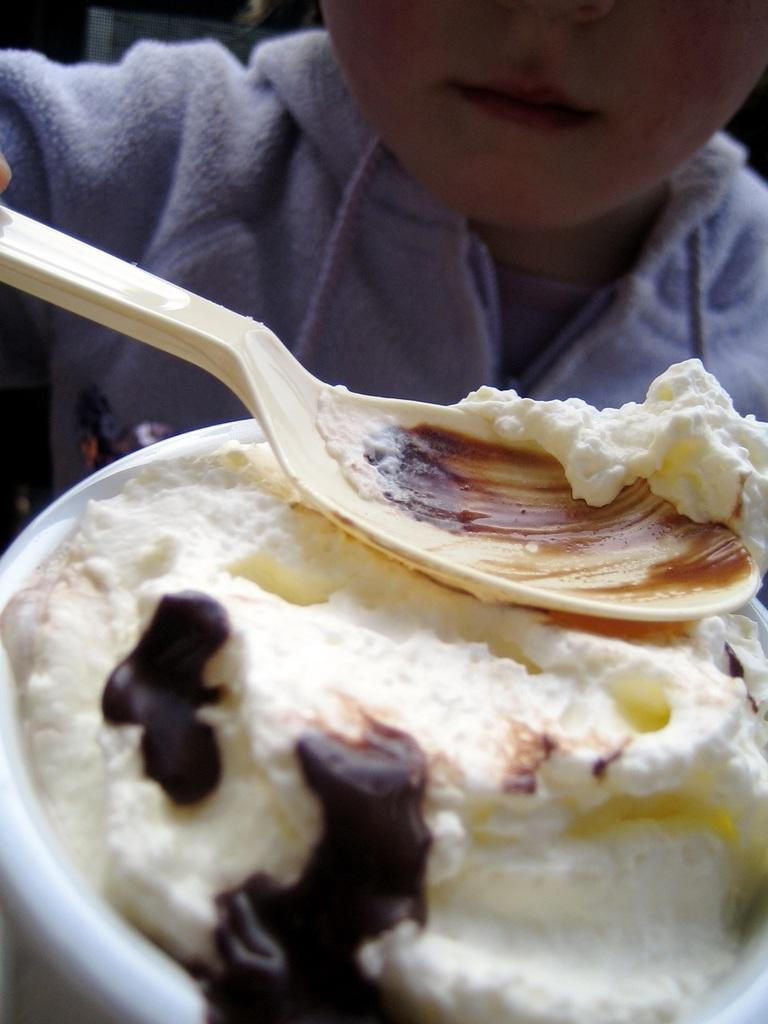What is the main subject of the image? There is a person in the image. What is the person holding in the image? The person is holding a spoon. What else can be seen in the image besides the person? There is a cup in the image. What is inside the cup? The cup is filled with a spoon. What type of sponge can be seen on the person's collar in the image? There is no sponge or collar present on the person in the image. 